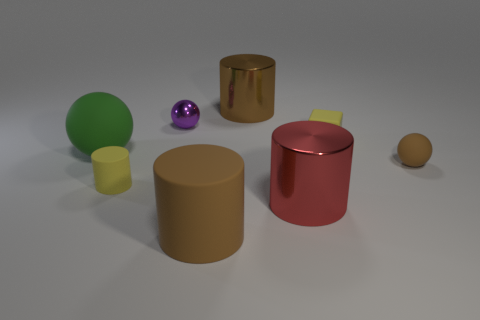What's the lighting like in this scene? The scene is softly lit from an angle that is not directly visible, casting gentle shadows and highlighting the shapes with diffused light, giving the scene a calm and controlled ambiance. 